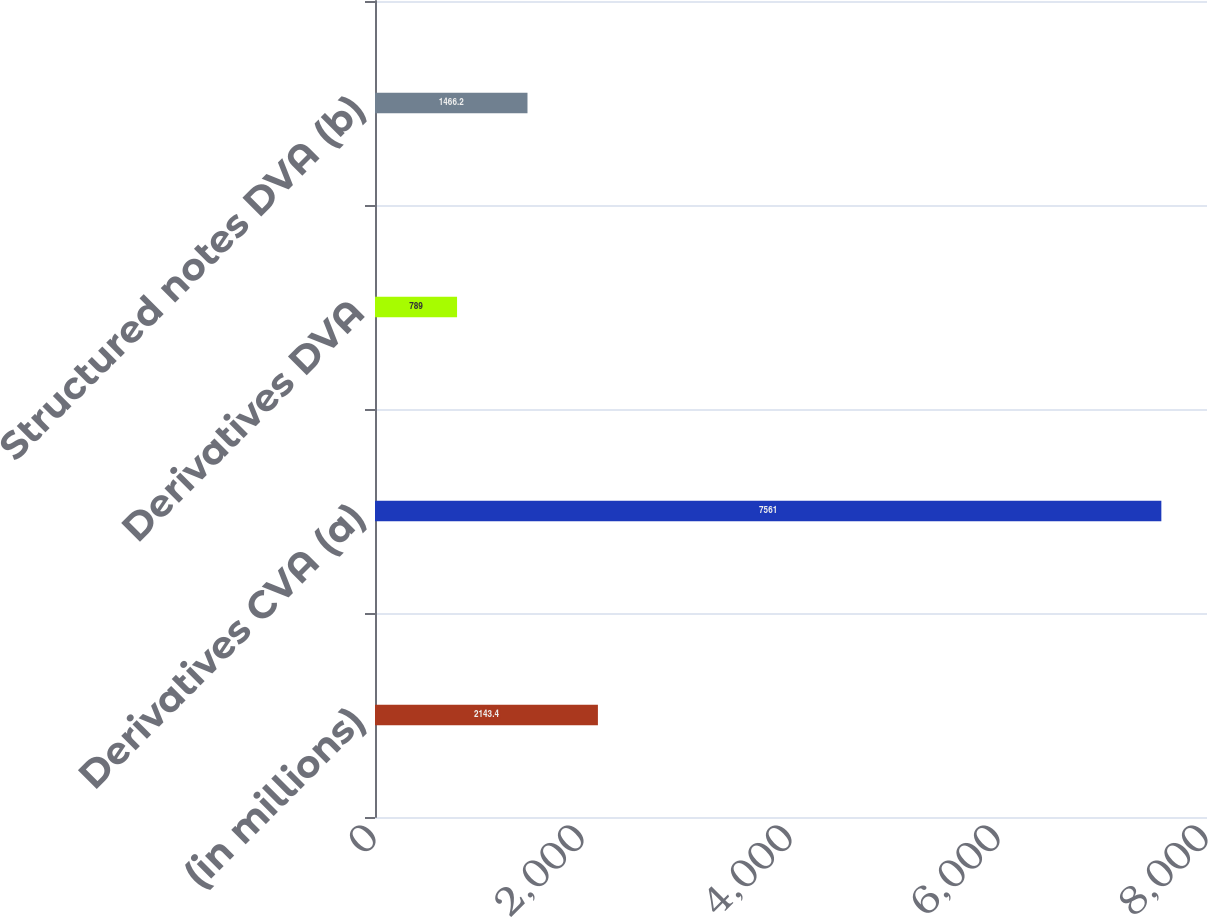Convert chart to OTSL. <chart><loc_0><loc_0><loc_500><loc_500><bar_chart><fcel>(in millions)<fcel>Derivatives CVA (a)<fcel>Derivatives DVA<fcel>Structured notes DVA (b)<nl><fcel>2143.4<fcel>7561<fcel>789<fcel>1466.2<nl></chart> 